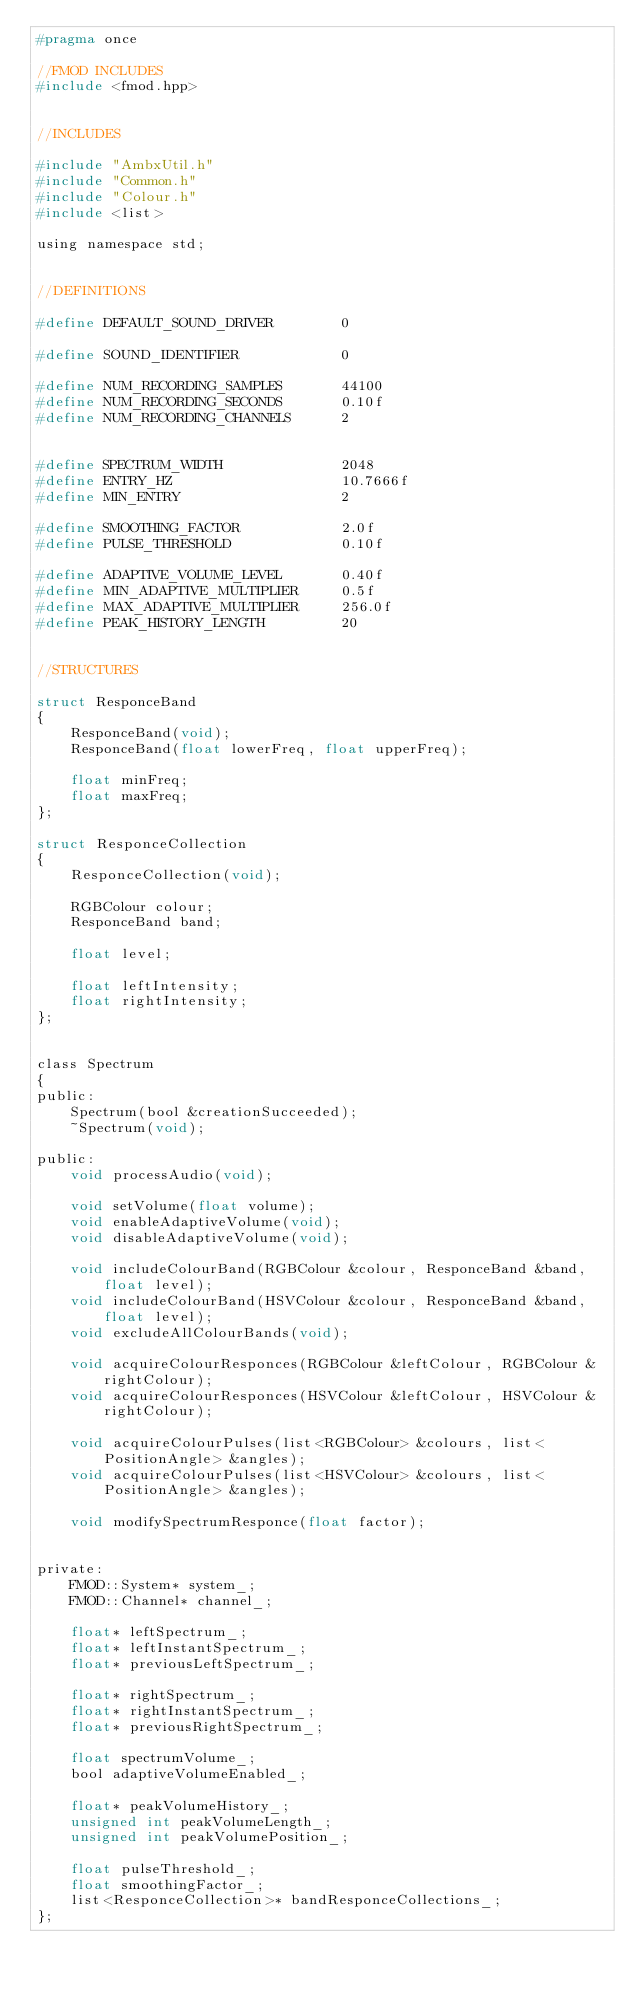Convert code to text. <code><loc_0><loc_0><loc_500><loc_500><_C_>#pragma once

//FMOD INCLUDES
#include <fmod.hpp>


//INCLUDES

#include "AmbxUtil.h"
#include "Common.h"
#include "Colour.h"
#include <list>

using namespace std;


//DEFINITIONS

#define DEFAULT_SOUND_DRIVER		0

#define SOUND_IDENTIFIER			0

#define NUM_RECORDING_SAMPLES		44100
#define	NUM_RECORDING_SECONDS		0.10f
#define NUM_RECORDING_CHANNELS		2


#define SPECTRUM_WIDTH				2048
#define ENTRY_HZ					10.7666f
#define MIN_ENTRY					2

#define SMOOTHING_FACTOR			2.0f
#define PULSE_THRESHOLD				0.10f

#define ADAPTIVE_VOLUME_LEVEL		0.40f
#define MIN_ADAPTIVE_MULTIPLIER		0.5f
#define MAX_ADAPTIVE_MULTIPLIER		256.0f
#define PEAK_HISTORY_LENGTH			20


//STRUCTURES

struct ResponceBand
{
	ResponceBand(void);
	ResponceBand(float lowerFreq, float upperFreq);

	float minFreq;
	float maxFreq;
};

struct ResponceCollection
{
	ResponceCollection(void);

	RGBColour colour;
	ResponceBand band;

	float level;

	float leftIntensity;
	float rightIntensity;
};


class Spectrum
{
public:
	Spectrum(bool &creationSucceeded);
	~Spectrum(void);

public:
	void processAudio(void);

	void setVolume(float volume);
	void enableAdaptiveVolume(void);
	void disableAdaptiveVolume(void);

	void includeColourBand(RGBColour &colour, ResponceBand &band, float level);
	void includeColourBand(HSVColour &colour, ResponceBand &band, float level);
	void excludeAllColourBands(void);

	void acquireColourResponces(RGBColour &leftColour, RGBColour &rightColour);
	void acquireColourResponces(HSVColour &leftColour, HSVColour &rightColour);

	void acquireColourPulses(list<RGBColour> &colours, list<PositionAngle> &angles);
	void acquireColourPulses(list<HSVColour> &colours, list<PositionAngle> &angles);

	void modifySpectrumResponce(float factor);


private:
	FMOD::System* system_;
	FMOD::Channel* channel_;

	float* leftSpectrum_;
	float* leftInstantSpectrum_;
	float* previousLeftSpectrum_;

	float* rightSpectrum_;
	float* rightInstantSpectrum_;
	float* previousRightSpectrum_;

	float spectrumVolume_;
	bool adaptiveVolumeEnabled_;

	float* peakVolumeHistory_;
	unsigned int peakVolumeLength_;
	unsigned int peakVolumePosition_;

	float pulseThreshold_;
	float smoothingFactor_;
	list<ResponceCollection>* bandResponceCollections_;
};
</code> 